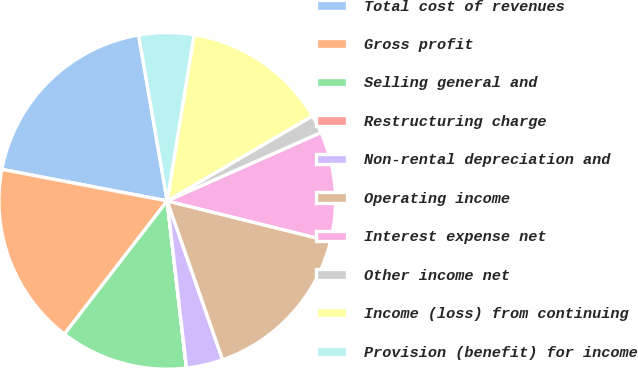<chart> <loc_0><loc_0><loc_500><loc_500><pie_chart><fcel>Total cost of revenues<fcel>Gross profit<fcel>Selling general and<fcel>Restructuring charge<fcel>Non-rental depreciation and<fcel>Operating income<fcel>Interest expense net<fcel>Other income net<fcel>Income (loss) from continuing<fcel>Provision (benefit) for income<nl><fcel>19.29%<fcel>17.54%<fcel>12.28%<fcel>0.01%<fcel>3.51%<fcel>15.79%<fcel>10.53%<fcel>1.76%<fcel>14.03%<fcel>5.27%<nl></chart> 